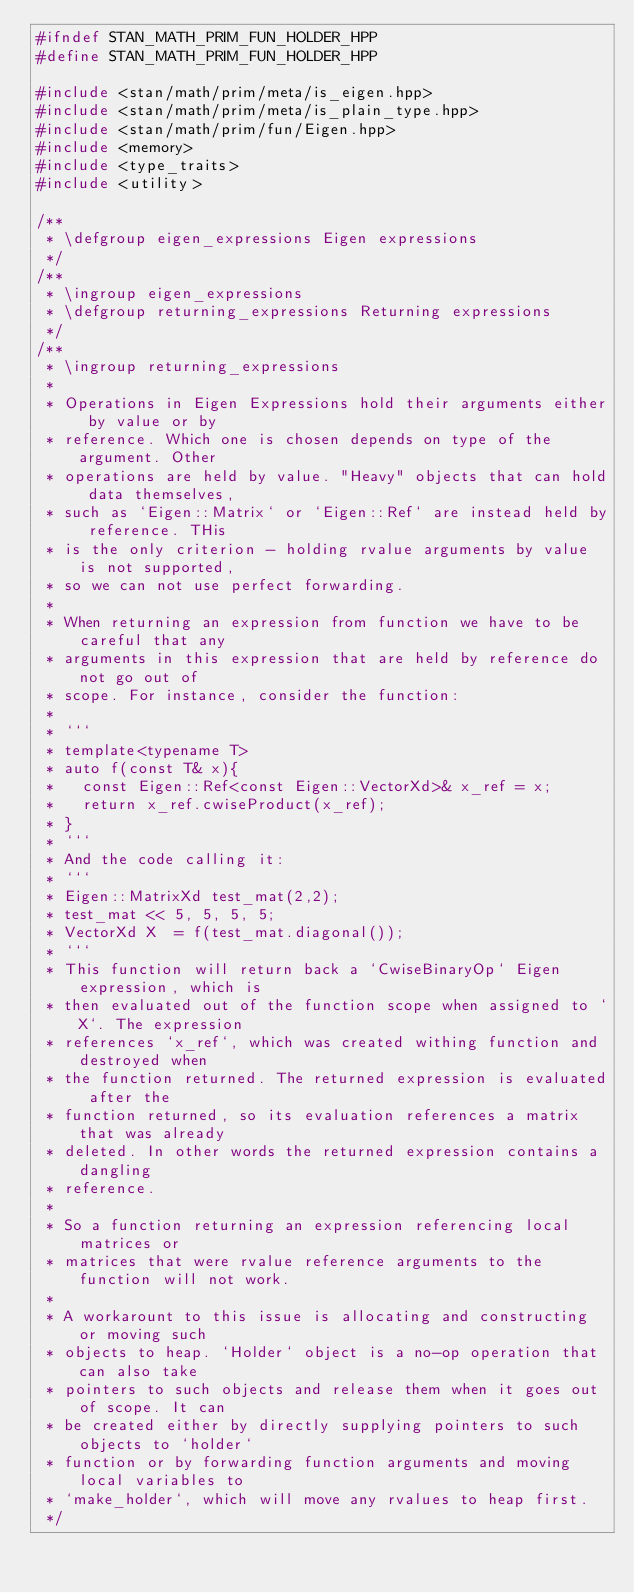<code> <loc_0><loc_0><loc_500><loc_500><_C++_>#ifndef STAN_MATH_PRIM_FUN_HOLDER_HPP
#define STAN_MATH_PRIM_FUN_HOLDER_HPP

#include <stan/math/prim/meta/is_eigen.hpp>
#include <stan/math/prim/meta/is_plain_type.hpp>
#include <stan/math/prim/fun/Eigen.hpp>
#include <memory>
#include <type_traits>
#include <utility>

/**
 * \defgroup eigen_expressions Eigen expressions
 */
/**
 * \ingroup eigen_expressions
 * \defgroup returning_expressions Returning expressions
 */
/**
 * \ingroup returning_expressions
 *
 * Operations in Eigen Expressions hold their arguments either by value or by
 * reference. Which one is chosen depends on type of the argument. Other
 * operations are held by value. "Heavy" objects that can hold data themselves,
 * such as `Eigen::Matrix` or `Eigen::Ref` are instead held by reference. THis
 * is the only criterion - holding rvalue arguments by value is not supported,
 * so we can not use perfect forwarding.
 *
 * When returning an expression from function we have to be careful that any
 * arguments in this expression that are held by reference do not go out of
 * scope. For instance, consider the function:
 *
 * ```
 * template<typename T>
 * auto f(const T& x){
 *   const Eigen::Ref<const Eigen::VectorXd>& x_ref = x;
 *   return x_ref.cwiseProduct(x_ref);
 * }
 * ```
 * And the code calling it:
 * ```
 * Eigen::MatrixXd test_mat(2,2);
 * test_mat << 5, 5, 5, 5;
 * VectorXd X  = f(test_mat.diagonal());
 * ```
 * This function will return back a `CwiseBinaryOp` Eigen expression, which is
 * then evaluated out of the function scope when assigned to `X`. The expression
 * references `x_ref`, which was created withing function and destroyed when
 * the function returned. The returned expression is evaluated after the
 * function returned, so its evaluation references a matrix that was already
 * deleted. In other words the returned expression contains a dangling
 * reference.
 *
 * So a function returning an expression referencing local matrices or
 * matrices that were rvalue reference arguments to the function will not work.
 *
 * A workarount to this issue is allocating and constructing or moving such
 * objects to heap. `Holder` object is a no-op operation that can also take
 * pointers to such objects and release them when it goes out of scope. It can
 * be created either by directly supplying pointers to such objects to `holder`
 * function or by forwarding function arguments and moving local variables to
 * `make_holder`, which will move any rvalues to heap first.
 */
</code> 